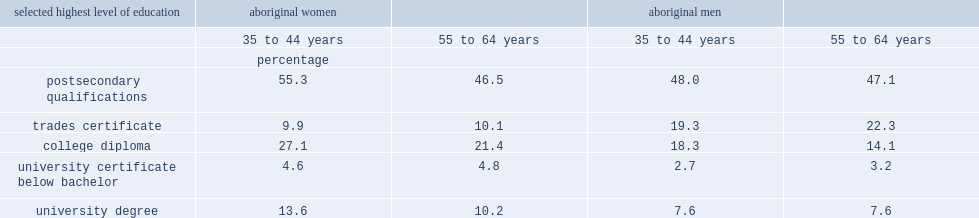Among younger aboriginal women, how many percent of women had a university degree? 13.6. Among aboriginal women aged 55 to 64, how many percent had a university degree? 10.2. Among aboriginal men, there was no difference between the two age groups in the proportions that held a university degree, what was the percent for both men aged 35 to 44 and 55 to 64 years? 7.6. Among aboriginal women aged 35 to 44, how many percent had a college diploma in 2011? 27.1. Among aboriginal women aged 55 to 64, how many percent had a college diploma in 2011? 21.4. Which age group of aboriginal men were also more likely to have a college diploma, aged 35 to 44 or those aged 55 to 64? 35 to 44 years. 